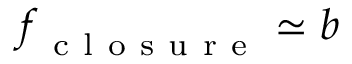Convert formula to latex. <formula><loc_0><loc_0><loc_500><loc_500>f _ { c l o s u r e } \simeq b</formula> 